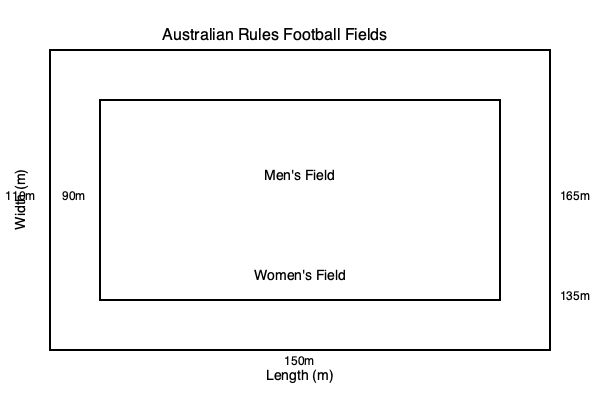Based on the diagram showing the field dimensions for men's and women's Australian rules football, calculate the percentage difference in total field area between the two formats. Round your answer to the nearest whole percentage. To calculate the percentage difference in total field area, we'll follow these steps:

1. Calculate the area of the men's field:
   Length = 165m, Width = 110m
   Area_men = 165m × 110m = 18,150 m²

2. Calculate the area of the women's field:
   Length = 135m, Width = 90m
   Area_women = 135m × 90m = 12,150 m²

3. Calculate the difference in area:
   Difference = Area_men - Area_women
   Difference = 18,150 m² - 12,150 m² = 6,000 m²

4. Calculate the percentage difference:
   Percentage difference = (Difference / Area_men) × 100
   Percentage difference = (6,000 m² / 18,150 m²) × 100 = 33.06%

5. Round to the nearest whole percentage:
   33.06% rounds to 33%

Therefore, the men's field is approximately 33% larger than the women's field.
Answer: 33% 